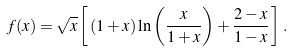<formula> <loc_0><loc_0><loc_500><loc_500>f ( x ) = \sqrt { x } \left [ \, ( 1 + x ) \ln \left ( \frac { x } { 1 + x } \right ) + \frac { 2 - x } { 1 - x } \, \right ] \, .</formula> 